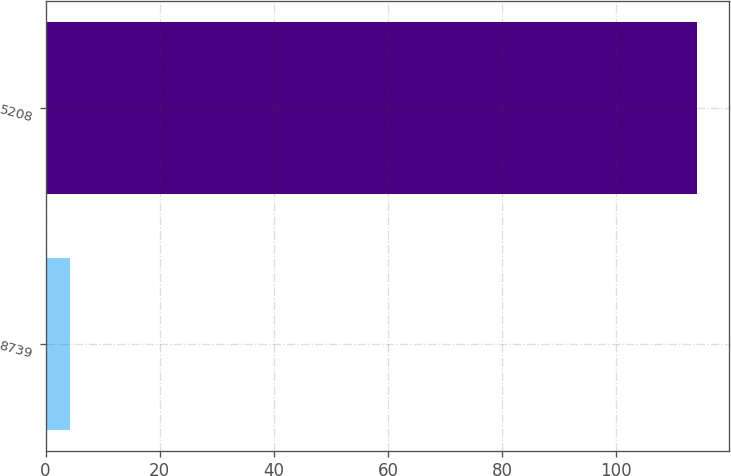Convert chart. <chart><loc_0><loc_0><loc_500><loc_500><bar_chart><fcel>8739<fcel>5208<nl><fcel>4.3<fcel>114.1<nl></chart> 